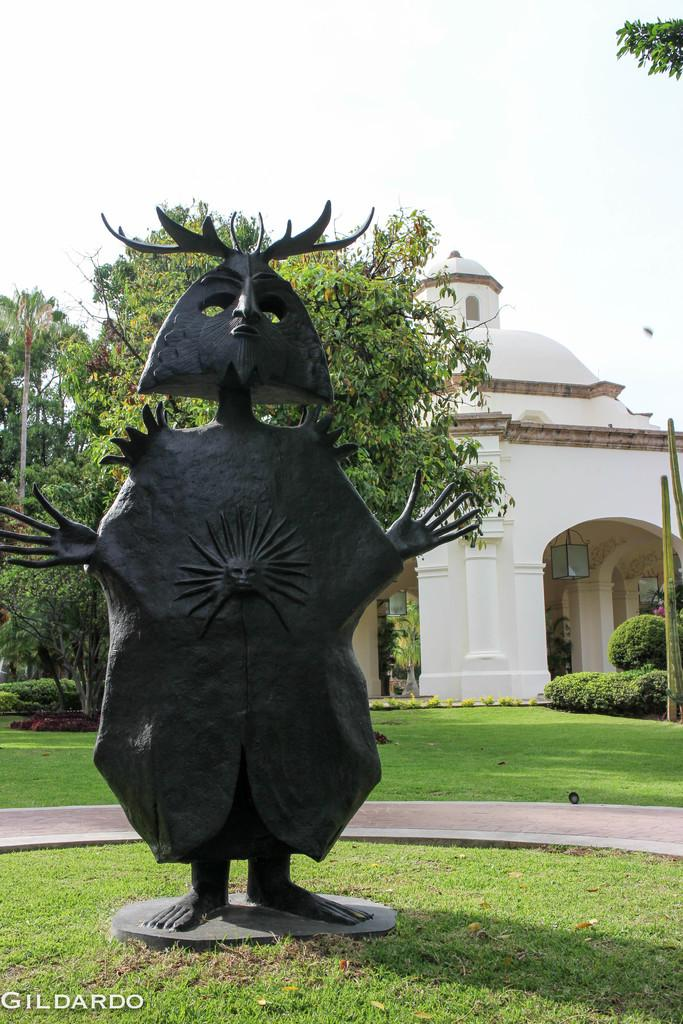What is the main subject in the image? There is a statue in the image. What other structures can be seen in the image? There is a house in the image. What type of vegetation is present in the image? There is grass, plants, and trees in the image. What is visible in the background of the image? The sky is visible in the background of the image. Can you describe any additional features of the image? There is a watermark on the image. What type of alarm can be heard going off in the image? There is no alarm present in the image, and therefore no sound can be heard. 